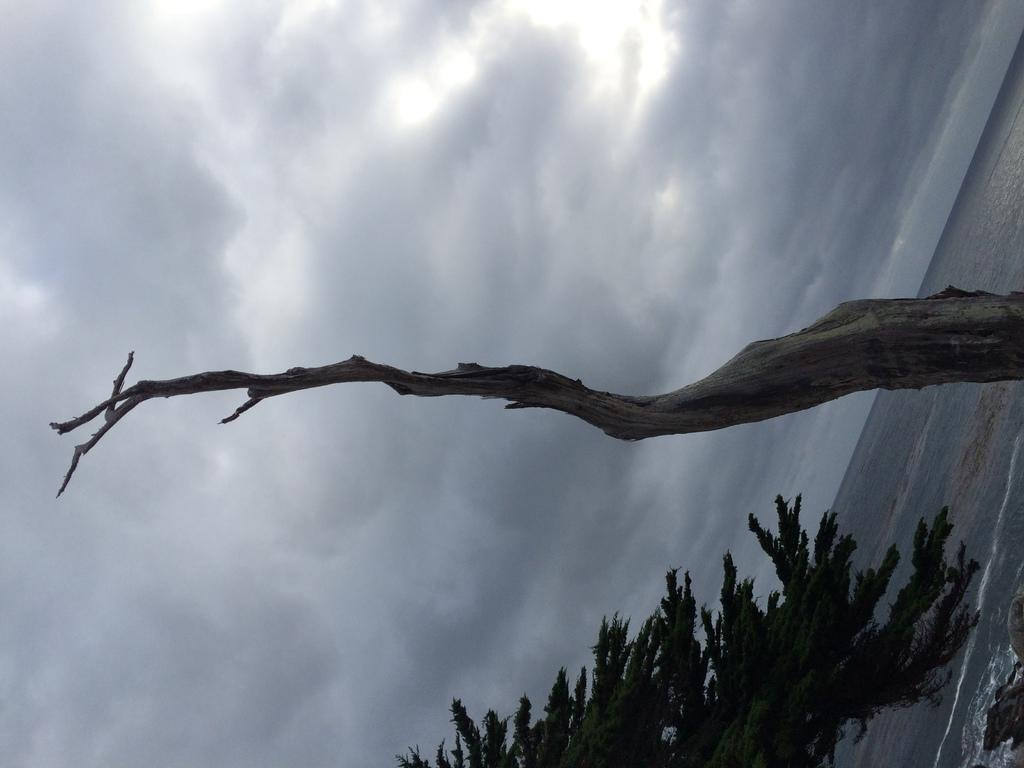What is the main subject in the center of the image? There is a tree trunk in the center of the image. What other tree can be seen in the image? There is a tree at the bottom of the image. What can be seen on the right side of the image? There is a water body on the right side of the image. What is visible in the background of the image? The sky is visible in the image. How would you describe the sky in the image? The sky is cloudy in the image. How many rabbits are swimming in the water body in the image? There are no rabbits present in the image, and therefore no rabbits can be seen swimming in the water body. What rate of speed are the fish moving in the water body in the image? There are no fish present in the image, so it is not possible to determine their rate of speed. 